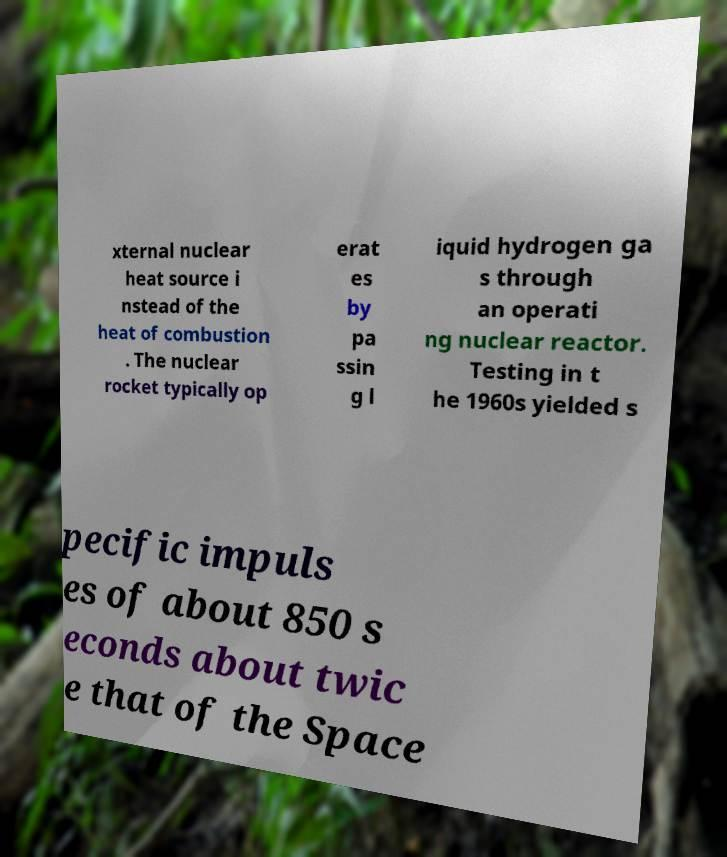I need the written content from this picture converted into text. Can you do that? xternal nuclear heat source i nstead of the heat of combustion . The nuclear rocket typically op erat es by pa ssin g l iquid hydrogen ga s through an operati ng nuclear reactor. Testing in t he 1960s yielded s pecific impuls es of about 850 s econds about twic e that of the Space 